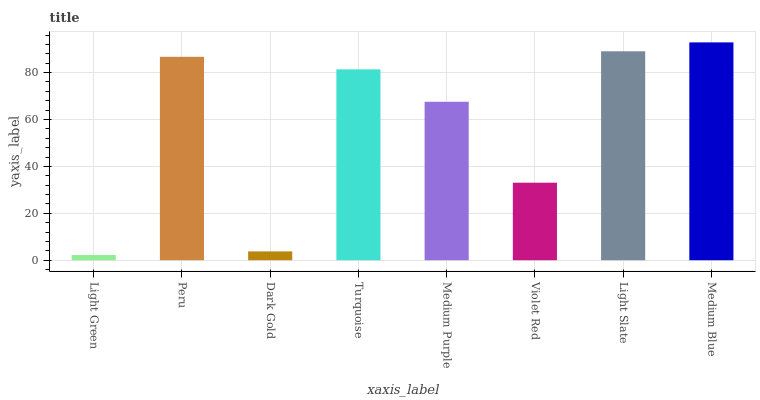Is Light Green the minimum?
Answer yes or no. Yes. Is Medium Blue the maximum?
Answer yes or no. Yes. Is Peru the minimum?
Answer yes or no. No. Is Peru the maximum?
Answer yes or no. No. Is Peru greater than Light Green?
Answer yes or no. Yes. Is Light Green less than Peru?
Answer yes or no. Yes. Is Light Green greater than Peru?
Answer yes or no. No. Is Peru less than Light Green?
Answer yes or no. No. Is Turquoise the high median?
Answer yes or no. Yes. Is Medium Purple the low median?
Answer yes or no. Yes. Is Medium Blue the high median?
Answer yes or no. No. Is Violet Red the low median?
Answer yes or no. No. 